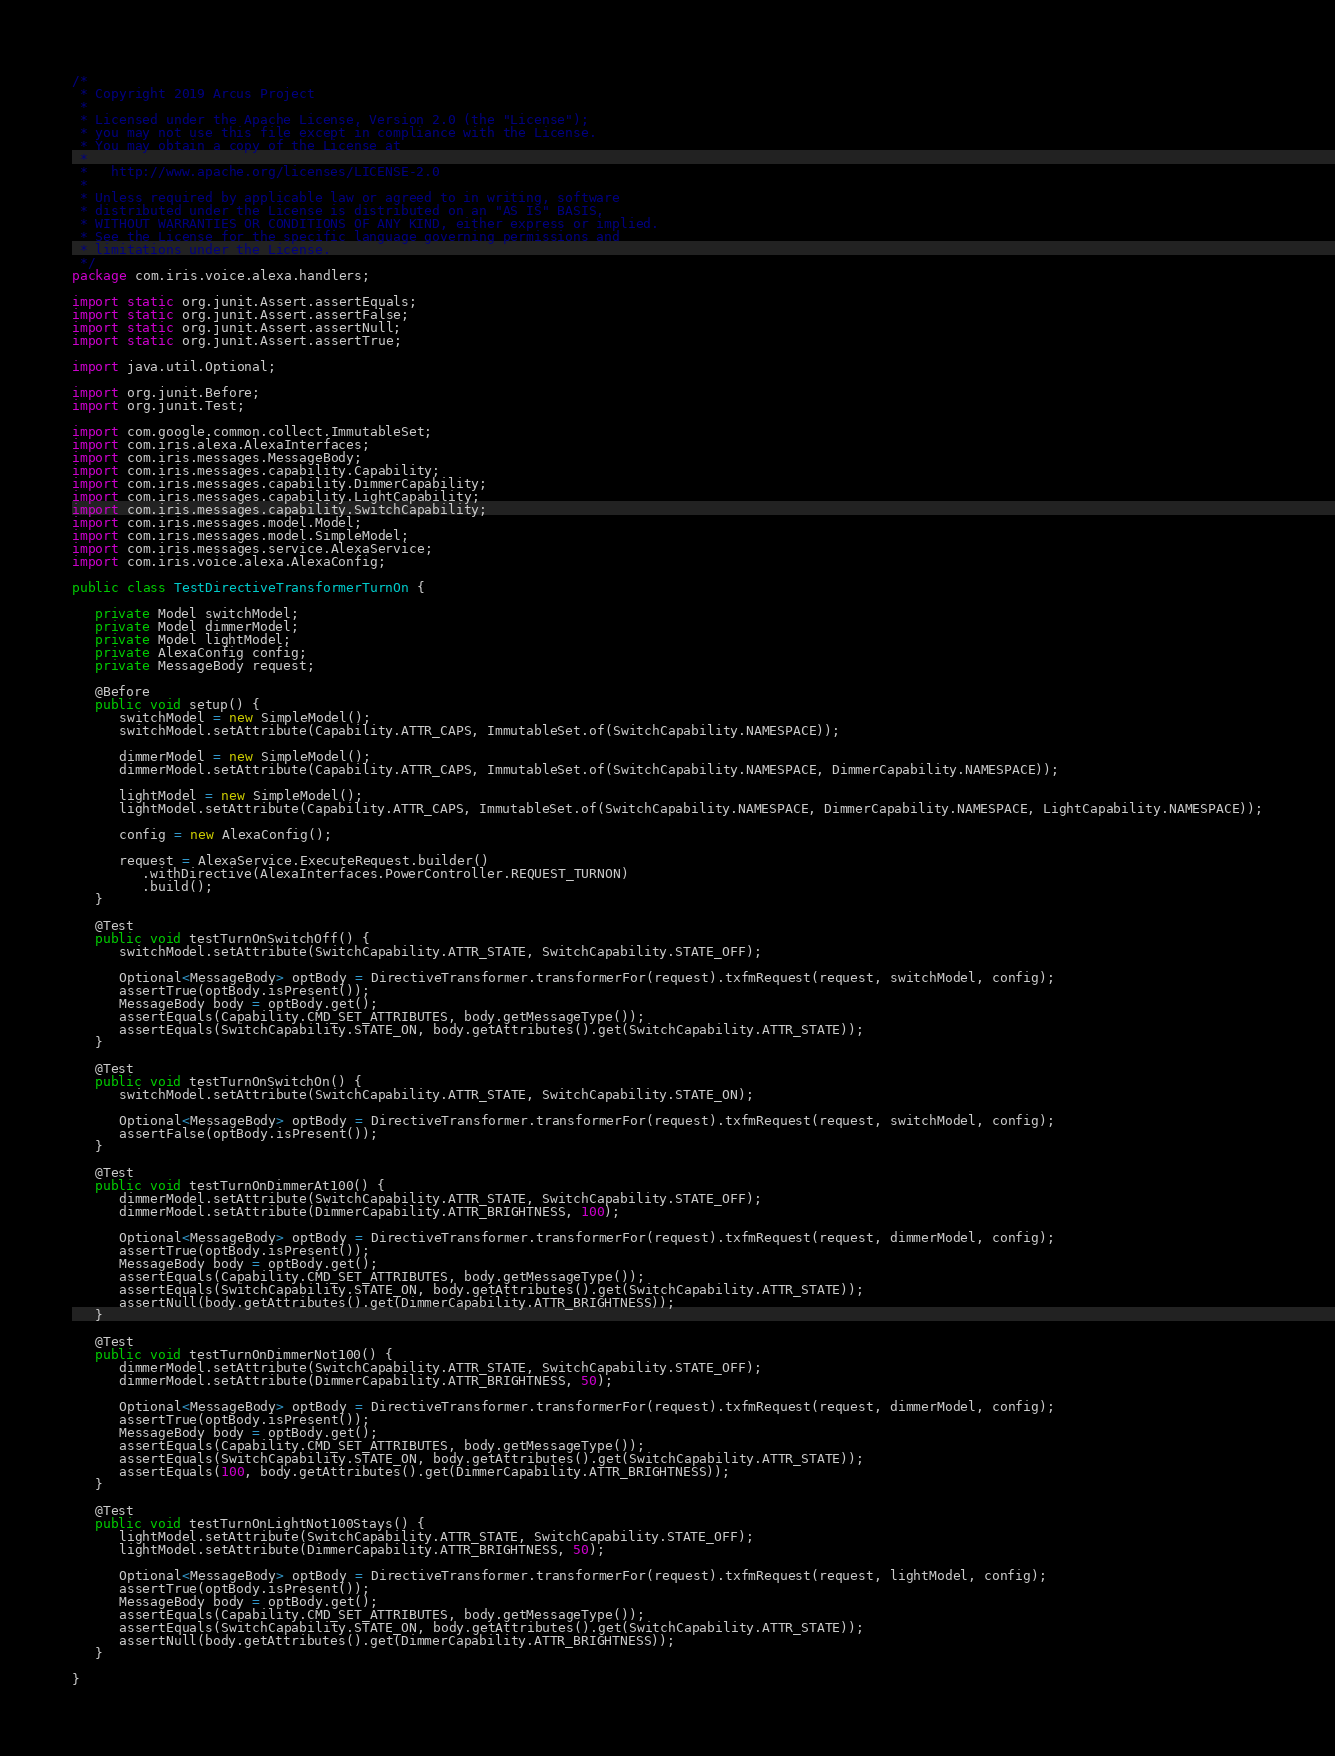<code> <loc_0><loc_0><loc_500><loc_500><_Java_>/*
 * Copyright 2019 Arcus Project
 *
 * Licensed under the Apache License, Version 2.0 (the "License");
 * you may not use this file except in compliance with the License.
 * You may obtain a copy of the License at
 *
 *   http://www.apache.org/licenses/LICENSE-2.0
 *
 * Unless required by applicable law or agreed to in writing, software
 * distributed under the License is distributed on an "AS IS" BASIS,
 * WITHOUT WARRANTIES OR CONDITIONS OF ANY KIND, either express or implied.
 * See the License for the specific language governing permissions and
 * limitations under the License.
 */
package com.iris.voice.alexa.handlers;

import static org.junit.Assert.assertEquals;
import static org.junit.Assert.assertFalse;
import static org.junit.Assert.assertNull;
import static org.junit.Assert.assertTrue;

import java.util.Optional;

import org.junit.Before;
import org.junit.Test;

import com.google.common.collect.ImmutableSet;
import com.iris.alexa.AlexaInterfaces;
import com.iris.messages.MessageBody;
import com.iris.messages.capability.Capability;
import com.iris.messages.capability.DimmerCapability;
import com.iris.messages.capability.LightCapability;
import com.iris.messages.capability.SwitchCapability;
import com.iris.messages.model.Model;
import com.iris.messages.model.SimpleModel;
import com.iris.messages.service.AlexaService;
import com.iris.voice.alexa.AlexaConfig;

public class TestDirectiveTransformerTurnOn {

   private Model switchModel;
   private Model dimmerModel;
   private Model lightModel;
   private AlexaConfig config;
   private MessageBody request;

   @Before
   public void setup() {
      switchModel = new SimpleModel();
      switchModel.setAttribute(Capability.ATTR_CAPS, ImmutableSet.of(SwitchCapability.NAMESPACE));

      dimmerModel = new SimpleModel();
      dimmerModel.setAttribute(Capability.ATTR_CAPS, ImmutableSet.of(SwitchCapability.NAMESPACE, DimmerCapability.NAMESPACE));

      lightModel = new SimpleModel();
      lightModel.setAttribute(Capability.ATTR_CAPS, ImmutableSet.of(SwitchCapability.NAMESPACE, DimmerCapability.NAMESPACE, LightCapability.NAMESPACE));

      config = new AlexaConfig();

      request = AlexaService.ExecuteRequest.builder()
         .withDirective(AlexaInterfaces.PowerController.REQUEST_TURNON)
         .build();
   }

   @Test
   public void testTurnOnSwitchOff() {
      switchModel.setAttribute(SwitchCapability.ATTR_STATE, SwitchCapability.STATE_OFF);

      Optional<MessageBody> optBody = DirectiveTransformer.transformerFor(request).txfmRequest(request, switchModel, config);
      assertTrue(optBody.isPresent());
      MessageBody body = optBody.get();
      assertEquals(Capability.CMD_SET_ATTRIBUTES, body.getMessageType());
      assertEquals(SwitchCapability.STATE_ON, body.getAttributes().get(SwitchCapability.ATTR_STATE));
   }

   @Test
   public void testTurnOnSwitchOn() {
      switchModel.setAttribute(SwitchCapability.ATTR_STATE, SwitchCapability.STATE_ON);

      Optional<MessageBody> optBody = DirectiveTransformer.transformerFor(request).txfmRequest(request, switchModel, config);
      assertFalse(optBody.isPresent());
   }

   @Test
   public void testTurnOnDimmerAt100() {
      dimmerModel.setAttribute(SwitchCapability.ATTR_STATE, SwitchCapability.STATE_OFF);
      dimmerModel.setAttribute(DimmerCapability.ATTR_BRIGHTNESS, 100);

      Optional<MessageBody> optBody = DirectiveTransformer.transformerFor(request).txfmRequest(request, dimmerModel, config);
      assertTrue(optBody.isPresent());
      MessageBody body = optBody.get();
      assertEquals(Capability.CMD_SET_ATTRIBUTES, body.getMessageType());
      assertEquals(SwitchCapability.STATE_ON, body.getAttributes().get(SwitchCapability.ATTR_STATE));
      assertNull(body.getAttributes().get(DimmerCapability.ATTR_BRIGHTNESS));
   }

   @Test
   public void testTurnOnDimmerNot100() {
      dimmerModel.setAttribute(SwitchCapability.ATTR_STATE, SwitchCapability.STATE_OFF);
      dimmerModel.setAttribute(DimmerCapability.ATTR_BRIGHTNESS, 50);

      Optional<MessageBody> optBody = DirectiveTransformer.transformerFor(request).txfmRequest(request, dimmerModel, config);
      assertTrue(optBody.isPresent());
      MessageBody body = optBody.get();
      assertEquals(Capability.CMD_SET_ATTRIBUTES, body.getMessageType());
      assertEquals(SwitchCapability.STATE_ON, body.getAttributes().get(SwitchCapability.ATTR_STATE));
      assertEquals(100, body.getAttributes().get(DimmerCapability.ATTR_BRIGHTNESS));
   }

   @Test
   public void testTurnOnLightNot100Stays() {
      lightModel.setAttribute(SwitchCapability.ATTR_STATE, SwitchCapability.STATE_OFF);
      lightModel.setAttribute(DimmerCapability.ATTR_BRIGHTNESS, 50);

      Optional<MessageBody> optBody = DirectiveTransformer.transformerFor(request).txfmRequest(request, lightModel, config);
      assertTrue(optBody.isPresent());
      MessageBody body = optBody.get();
      assertEquals(Capability.CMD_SET_ATTRIBUTES, body.getMessageType());
      assertEquals(SwitchCapability.STATE_ON, body.getAttributes().get(SwitchCapability.ATTR_STATE));
      assertNull(body.getAttributes().get(DimmerCapability.ATTR_BRIGHTNESS));
   }

}

</code> 